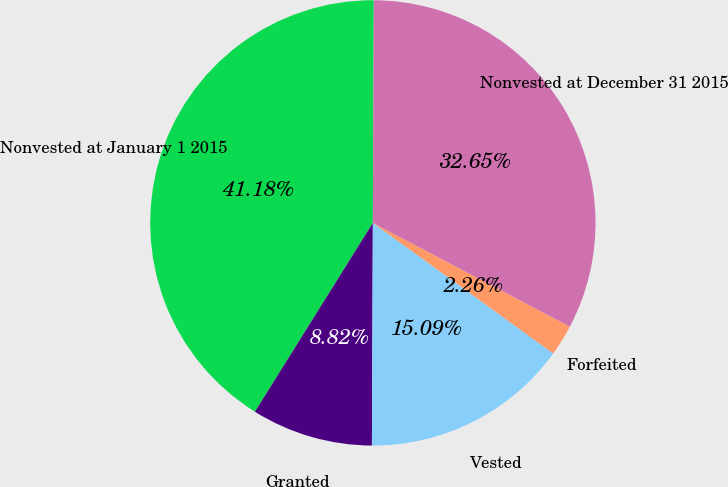Convert chart. <chart><loc_0><loc_0><loc_500><loc_500><pie_chart><fcel>Nonvested at January 1 2015<fcel>Granted<fcel>Vested<fcel>Forfeited<fcel>Nonvested at December 31 2015<nl><fcel>41.18%<fcel>8.82%<fcel>15.09%<fcel>2.26%<fcel>32.65%<nl></chart> 